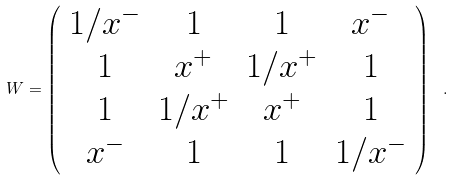Convert formula to latex. <formula><loc_0><loc_0><loc_500><loc_500>W = \left ( \begin{array} { c c c c } 1 / x ^ { - } & 1 & 1 & x ^ { - } \\ 1 & x ^ { + } & 1 / x ^ { + } & 1 \\ 1 & 1 / x ^ { + } & x ^ { + } & 1 \\ x ^ { - } & 1 & 1 & 1 / x ^ { - } \end{array} \right ) \ .</formula> 